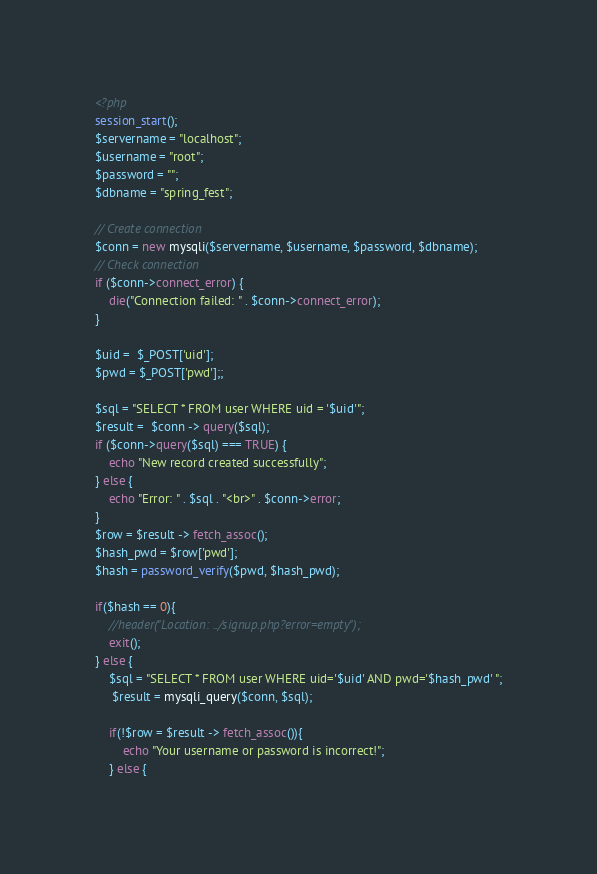<code> <loc_0><loc_0><loc_500><loc_500><_PHP_><?php
session_start();
$servername = "localhost";
$username = "root";
$password = "";
$dbname = "spring_fest";

// Create connection
$conn = new mysqli($servername, $username, $password, $dbname);
// Check connection
if ($conn->connect_error) {
    die("Connection failed: " . $conn->connect_error);
} 

$uid =  $_POST['uid'];
$pwd = $_POST['pwd'];;

$sql = "SELECT * FROM user WHERE uid = '$uid'";
$result =  $conn -> query($sql);
if ($conn->query($sql) === TRUE) {
    echo "New record created successfully";
} else {
    echo "Error: " . $sql . "<br>" . $conn->error;
}
$row = $result -> fetch_assoc();
$hash_pwd = $row['pwd'];
$hash = password_verify($pwd, $hash_pwd);

if($hash == 0){
    //header("Location: ../signup.php?error=empty");
    exit();
} else {
    $sql = "SELECT * FROM user WHERE uid='$uid' AND pwd='$hash_pwd' ";
     $result = mysqli_query($conn, $sql);

    if(!$row = $result -> fetch_assoc()){
        echo "Your username or password is incorrect!";
    } else {</code> 